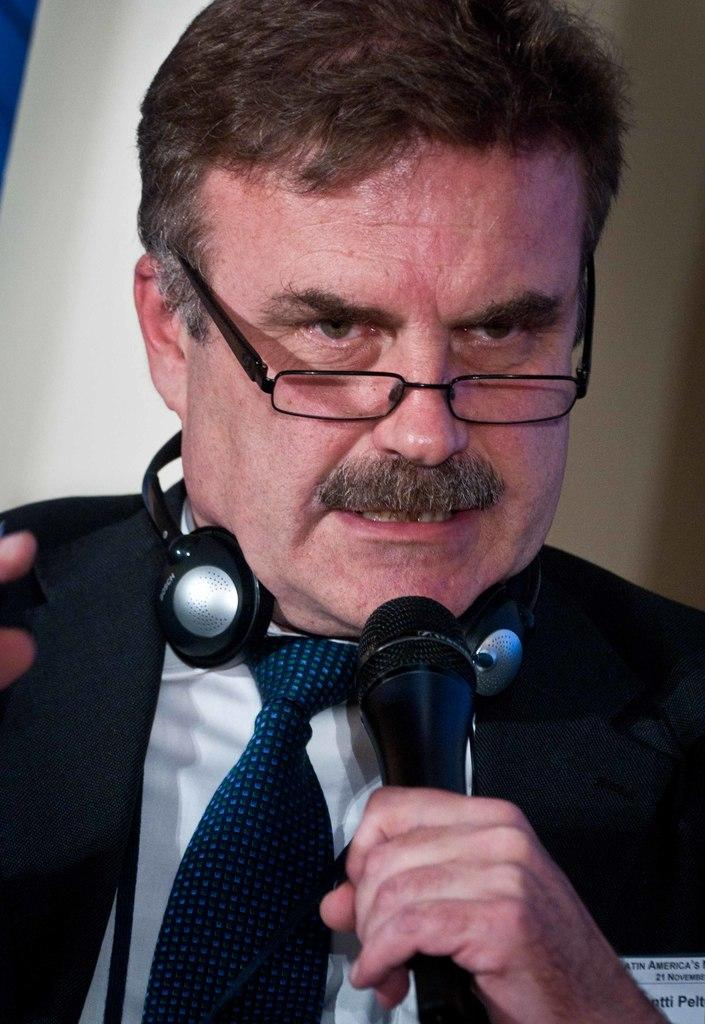Who is the main subject in the image? There is a man in the image. What can be seen on the man's face? The man is wearing spectacles. What color is the coat the man is wearing? The man is wearing a black color coat. What is the man holding in the image? The man is holding a mic. What is located around the man's neck? There is a headset around the man's neck. How many airplanes can be seen in the image? There are no airplanes present in the image. What word is the man trying to measure in the image? There is no indication in the image that the man is measuring or using any words. 